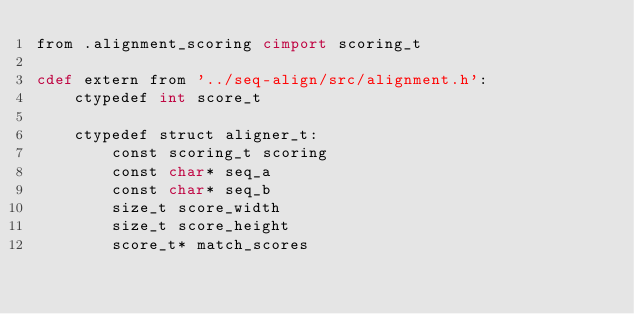Convert code to text. <code><loc_0><loc_0><loc_500><loc_500><_Cython_>from .alignment_scoring cimport scoring_t

cdef extern from '../seq-align/src/alignment.h':
    ctypedef int score_t

    ctypedef struct aligner_t:
        const scoring_t scoring
        const char* seq_a
        const char* seq_b
        size_t score_width
        size_t score_height
        score_t* match_scores</code> 